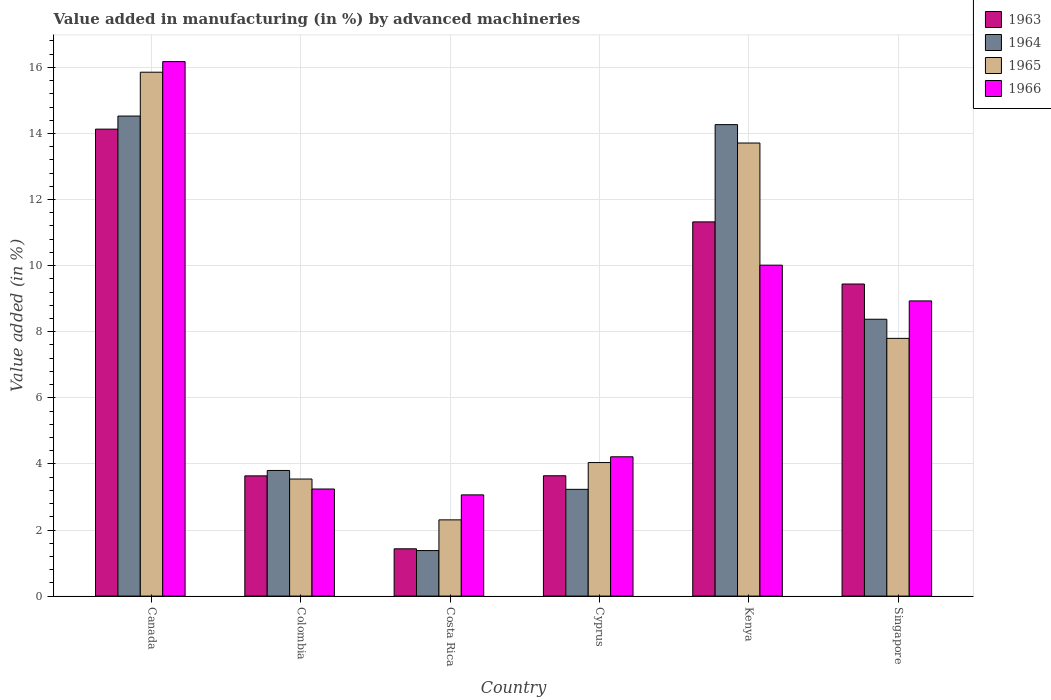How many groups of bars are there?
Your response must be concise. 6. Are the number of bars per tick equal to the number of legend labels?
Offer a very short reply. Yes. Are the number of bars on each tick of the X-axis equal?
Your answer should be compact. Yes. What is the label of the 4th group of bars from the left?
Provide a short and direct response. Cyprus. In how many cases, is the number of bars for a given country not equal to the number of legend labels?
Provide a short and direct response. 0. What is the percentage of value added in manufacturing by advanced machineries in 1965 in Cyprus?
Your response must be concise. 4.04. Across all countries, what is the maximum percentage of value added in manufacturing by advanced machineries in 1963?
Provide a short and direct response. 14.13. Across all countries, what is the minimum percentage of value added in manufacturing by advanced machineries in 1964?
Your response must be concise. 1.38. In which country was the percentage of value added in manufacturing by advanced machineries in 1966 maximum?
Offer a very short reply. Canada. What is the total percentage of value added in manufacturing by advanced machineries in 1963 in the graph?
Offer a terse response. 43.61. What is the difference between the percentage of value added in manufacturing by advanced machineries in 1963 in Colombia and that in Kenya?
Offer a terse response. -7.69. What is the difference between the percentage of value added in manufacturing by advanced machineries in 1965 in Canada and the percentage of value added in manufacturing by advanced machineries in 1964 in Colombia?
Ensure brevity in your answer.  12.05. What is the average percentage of value added in manufacturing by advanced machineries in 1966 per country?
Your answer should be very brief. 7.61. What is the difference between the percentage of value added in manufacturing by advanced machineries of/in 1966 and percentage of value added in manufacturing by advanced machineries of/in 1964 in Kenya?
Offer a terse response. -4.25. In how many countries, is the percentage of value added in manufacturing by advanced machineries in 1966 greater than 10 %?
Ensure brevity in your answer.  2. What is the ratio of the percentage of value added in manufacturing by advanced machineries in 1966 in Canada to that in Costa Rica?
Your response must be concise. 5.28. Is the percentage of value added in manufacturing by advanced machineries in 1966 in Colombia less than that in Kenya?
Make the answer very short. Yes. What is the difference between the highest and the second highest percentage of value added in manufacturing by advanced machineries in 1966?
Your response must be concise. 7.24. What is the difference between the highest and the lowest percentage of value added in manufacturing by advanced machineries in 1963?
Offer a terse response. 12.7. Is the sum of the percentage of value added in manufacturing by advanced machineries in 1965 in Colombia and Cyprus greater than the maximum percentage of value added in manufacturing by advanced machineries in 1964 across all countries?
Offer a very short reply. No. Is it the case that in every country, the sum of the percentage of value added in manufacturing by advanced machineries in 1966 and percentage of value added in manufacturing by advanced machineries in 1964 is greater than the sum of percentage of value added in manufacturing by advanced machineries in 1965 and percentage of value added in manufacturing by advanced machineries in 1963?
Make the answer very short. No. What does the 3rd bar from the left in Canada represents?
Make the answer very short. 1965. Are all the bars in the graph horizontal?
Offer a terse response. No. How many countries are there in the graph?
Give a very brief answer. 6. Are the values on the major ticks of Y-axis written in scientific E-notation?
Your response must be concise. No. Does the graph contain any zero values?
Keep it short and to the point. No. Where does the legend appear in the graph?
Your response must be concise. Top right. How many legend labels are there?
Offer a terse response. 4. What is the title of the graph?
Keep it short and to the point. Value added in manufacturing (in %) by advanced machineries. What is the label or title of the Y-axis?
Offer a very short reply. Value added (in %). What is the Value added (in %) of 1963 in Canada?
Give a very brief answer. 14.13. What is the Value added (in %) in 1964 in Canada?
Offer a very short reply. 14.53. What is the Value added (in %) of 1965 in Canada?
Your answer should be very brief. 15.85. What is the Value added (in %) in 1966 in Canada?
Provide a succinct answer. 16.17. What is the Value added (in %) of 1963 in Colombia?
Provide a short and direct response. 3.64. What is the Value added (in %) in 1964 in Colombia?
Ensure brevity in your answer.  3.8. What is the Value added (in %) in 1965 in Colombia?
Your answer should be very brief. 3.54. What is the Value added (in %) in 1966 in Colombia?
Keep it short and to the point. 3.24. What is the Value added (in %) of 1963 in Costa Rica?
Offer a very short reply. 1.43. What is the Value added (in %) in 1964 in Costa Rica?
Offer a very short reply. 1.38. What is the Value added (in %) of 1965 in Costa Rica?
Give a very brief answer. 2.31. What is the Value added (in %) of 1966 in Costa Rica?
Keep it short and to the point. 3.06. What is the Value added (in %) in 1963 in Cyprus?
Offer a very short reply. 3.64. What is the Value added (in %) of 1964 in Cyprus?
Provide a succinct answer. 3.23. What is the Value added (in %) of 1965 in Cyprus?
Give a very brief answer. 4.04. What is the Value added (in %) of 1966 in Cyprus?
Provide a succinct answer. 4.22. What is the Value added (in %) in 1963 in Kenya?
Provide a short and direct response. 11.32. What is the Value added (in %) of 1964 in Kenya?
Your answer should be compact. 14.27. What is the Value added (in %) of 1965 in Kenya?
Give a very brief answer. 13.71. What is the Value added (in %) of 1966 in Kenya?
Your answer should be compact. 10.01. What is the Value added (in %) of 1963 in Singapore?
Keep it short and to the point. 9.44. What is the Value added (in %) of 1964 in Singapore?
Keep it short and to the point. 8.38. What is the Value added (in %) of 1965 in Singapore?
Give a very brief answer. 7.8. What is the Value added (in %) in 1966 in Singapore?
Give a very brief answer. 8.93. Across all countries, what is the maximum Value added (in %) of 1963?
Provide a short and direct response. 14.13. Across all countries, what is the maximum Value added (in %) of 1964?
Ensure brevity in your answer.  14.53. Across all countries, what is the maximum Value added (in %) of 1965?
Keep it short and to the point. 15.85. Across all countries, what is the maximum Value added (in %) of 1966?
Offer a very short reply. 16.17. Across all countries, what is the minimum Value added (in %) of 1963?
Provide a short and direct response. 1.43. Across all countries, what is the minimum Value added (in %) of 1964?
Provide a succinct answer. 1.38. Across all countries, what is the minimum Value added (in %) in 1965?
Keep it short and to the point. 2.31. Across all countries, what is the minimum Value added (in %) in 1966?
Provide a short and direct response. 3.06. What is the total Value added (in %) of 1963 in the graph?
Keep it short and to the point. 43.61. What is the total Value added (in %) of 1964 in the graph?
Your answer should be very brief. 45.58. What is the total Value added (in %) in 1965 in the graph?
Provide a short and direct response. 47.25. What is the total Value added (in %) in 1966 in the graph?
Offer a very short reply. 45.64. What is the difference between the Value added (in %) of 1963 in Canada and that in Colombia?
Your answer should be compact. 10.49. What is the difference between the Value added (in %) of 1964 in Canada and that in Colombia?
Offer a terse response. 10.72. What is the difference between the Value added (in %) of 1965 in Canada and that in Colombia?
Keep it short and to the point. 12.31. What is the difference between the Value added (in %) in 1966 in Canada and that in Colombia?
Keep it short and to the point. 12.93. What is the difference between the Value added (in %) of 1963 in Canada and that in Costa Rica?
Make the answer very short. 12.7. What is the difference between the Value added (in %) of 1964 in Canada and that in Costa Rica?
Provide a succinct answer. 13.15. What is the difference between the Value added (in %) in 1965 in Canada and that in Costa Rica?
Make the answer very short. 13.55. What is the difference between the Value added (in %) of 1966 in Canada and that in Costa Rica?
Make the answer very short. 13.11. What is the difference between the Value added (in %) in 1963 in Canada and that in Cyprus?
Provide a short and direct response. 10.49. What is the difference between the Value added (in %) in 1964 in Canada and that in Cyprus?
Make the answer very short. 11.3. What is the difference between the Value added (in %) in 1965 in Canada and that in Cyprus?
Offer a terse response. 11.81. What is the difference between the Value added (in %) in 1966 in Canada and that in Cyprus?
Your answer should be very brief. 11.96. What is the difference between the Value added (in %) of 1963 in Canada and that in Kenya?
Offer a terse response. 2.81. What is the difference between the Value added (in %) in 1964 in Canada and that in Kenya?
Offer a very short reply. 0.26. What is the difference between the Value added (in %) of 1965 in Canada and that in Kenya?
Your response must be concise. 2.14. What is the difference between the Value added (in %) of 1966 in Canada and that in Kenya?
Your response must be concise. 6.16. What is the difference between the Value added (in %) in 1963 in Canada and that in Singapore?
Your answer should be very brief. 4.69. What is the difference between the Value added (in %) of 1964 in Canada and that in Singapore?
Provide a short and direct response. 6.15. What is the difference between the Value added (in %) of 1965 in Canada and that in Singapore?
Your answer should be very brief. 8.05. What is the difference between the Value added (in %) in 1966 in Canada and that in Singapore?
Provide a short and direct response. 7.24. What is the difference between the Value added (in %) of 1963 in Colombia and that in Costa Rica?
Your answer should be very brief. 2.21. What is the difference between the Value added (in %) in 1964 in Colombia and that in Costa Rica?
Your response must be concise. 2.42. What is the difference between the Value added (in %) in 1965 in Colombia and that in Costa Rica?
Your response must be concise. 1.24. What is the difference between the Value added (in %) of 1966 in Colombia and that in Costa Rica?
Give a very brief answer. 0.18. What is the difference between the Value added (in %) of 1963 in Colombia and that in Cyprus?
Provide a short and direct response. -0. What is the difference between the Value added (in %) in 1964 in Colombia and that in Cyprus?
Offer a terse response. 0.57. What is the difference between the Value added (in %) of 1965 in Colombia and that in Cyprus?
Offer a very short reply. -0.5. What is the difference between the Value added (in %) of 1966 in Colombia and that in Cyprus?
Your answer should be very brief. -0.97. What is the difference between the Value added (in %) of 1963 in Colombia and that in Kenya?
Make the answer very short. -7.69. What is the difference between the Value added (in %) of 1964 in Colombia and that in Kenya?
Ensure brevity in your answer.  -10.47. What is the difference between the Value added (in %) of 1965 in Colombia and that in Kenya?
Keep it short and to the point. -10.17. What is the difference between the Value added (in %) of 1966 in Colombia and that in Kenya?
Provide a short and direct response. -6.77. What is the difference between the Value added (in %) in 1963 in Colombia and that in Singapore?
Give a very brief answer. -5.81. What is the difference between the Value added (in %) of 1964 in Colombia and that in Singapore?
Provide a succinct answer. -4.58. What is the difference between the Value added (in %) in 1965 in Colombia and that in Singapore?
Provide a short and direct response. -4.26. What is the difference between the Value added (in %) in 1966 in Colombia and that in Singapore?
Offer a terse response. -5.69. What is the difference between the Value added (in %) of 1963 in Costa Rica and that in Cyprus?
Ensure brevity in your answer.  -2.21. What is the difference between the Value added (in %) of 1964 in Costa Rica and that in Cyprus?
Your response must be concise. -1.85. What is the difference between the Value added (in %) in 1965 in Costa Rica and that in Cyprus?
Keep it short and to the point. -1.73. What is the difference between the Value added (in %) in 1966 in Costa Rica and that in Cyprus?
Give a very brief answer. -1.15. What is the difference between the Value added (in %) of 1963 in Costa Rica and that in Kenya?
Your answer should be very brief. -9.89. What is the difference between the Value added (in %) of 1964 in Costa Rica and that in Kenya?
Ensure brevity in your answer.  -12.89. What is the difference between the Value added (in %) in 1965 in Costa Rica and that in Kenya?
Offer a very short reply. -11.4. What is the difference between the Value added (in %) of 1966 in Costa Rica and that in Kenya?
Provide a short and direct response. -6.95. What is the difference between the Value added (in %) of 1963 in Costa Rica and that in Singapore?
Give a very brief answer. -8.01. What is the difference between the Value added (in %) of 1964 in Costa Rica and that in Singapore?
Make the answer very short. -7. What is the difference between the Value added (in %) in 1965 in Costa Rica and that in Singapore?
Make the answer very short. -5.49. What is the difference between the Value added (in %) in 1966 in Costa Rica and that in Singapore?
Provide a succinct answer. -5.87. What is the difference between the Value added (in %) in 1963 in Cyprus and that in Kenya?
Make the answer very short. -7.68. What is the difference between the Value added (in %) in 1964 in Cyprus and that in Kenya?
Keep it short and to the point. -11.04. What is the difference between the Value added (in %) in 1965 in Cyprus and that in Kenya?
Your response must be concise. -9.67. What is the difference between the Value added (in %) of 1966 in Cyprus and that in Kenya?
Provide a succinct answer. -5.8. What is the difference between the Value added (in %) in 1963 in Cyprus and that in Singapore?
Make the answer very short. -5.8. What is the difference between the Value added (in %) in 1964 in Cyprus and that in Singapore?
Your answer should be very brief. -5.15. What is the difference between the Value added (in %) in 1965 in Cyprus and that in Singapore?
Provide a short and direct response. -3.76. What is the difference between the Value added (in %) in 1966 in Cyprus and that in Singapore?
Ensure brevity in your answer.  -4.72. What is the difference between the Value added (in %) of 1963 in Kenya and that in Singapore?
Give a very brief answer. 1.88. What is the difference between the Value added (in %) in 1964 in Kenya and that in Singapore?
Provide a short and direct response. 5.89. What is the difference between the Value added (in %) of 1965 in Kenya and that in Singapore?
Keep it short and to the point. 5.91. What is the difference between the Value added (in %) of 1966 in Kenya and that in Singapore?
Your answer should be very brief. 1.08. What is the difference between the Value added (in %) of 1963 in Canada and the Value added (in %) of 1964 in Colombia?
Your answer should be very brief. 10.33. What is the difference between the Value added (in %) of 1963 in Canada and the Value added (in %) of 1965 in Colombia?
Your answer should be compact. 10.59. What is the difference between the Value added (in %) of 1963 in Canada and the Value added (in %) of 1966 in Colombia?
Offer a very short reply. 10.89. What is the difference between the Value added (in %) in 1964 in Canada and the Value added (in %) in 1965 in Colombia?
Your response must be concise. 10.98. What is the difference between the Value added (in %) in 1964 in Canada and the Value added (in %) in 1966 in Colombia?
Give a very brief answer. 11.29. What is the difference between the Value added (in %) in 1965 in Canada and the Value added (in %) in 1966 in Colombia?
Offer a very short reply. 12.61. What is the difference between the Value added (in %) of 1963 in Canada and the Value added (in %) of 1964 in Costa Rica?
Your response must be concise. 12.75. What is the difference between the Value added (in %) of 1963 in Canada and the Value added (in %) of 1965 in Costa Rica?
Ensure brevity in your answer.  11.82. What is the difference between the Value added (in %) of 1963 in Canada and the Value added (in %) of 1966 in Costa Rica?
Your answer should be very brief. 11.07. What is the difference between the Value added (in %) of 1964 in Canada and the Value added (in %) of 1965 in Costa Rica?
Your response must be concise. 12.22. What is the difference between the Value added (in %) of 1964 in Canada and the Value added (in %) of 1966 in Costa Rica?
Offer a very short reply. 11.46. What is the difference between the Value added (in %) of 1965 in Canada and the Value added (in %) of 1966 in Costa Rica?
Your answer should be compact. 12.79. What is the difference between the Value added (in %) of 1963 in Canada and the Value added (in %) of 1964 in Cyprus?
Make the answer very short. 10.9. What is the difference between the Value added (in %) in 1963 in Canada and the Value added (in %) in 1965 in Cyprus?
Keep it short and to the point. 10.09. What is the difference between the Value added (in %) in 1963 in Canada and the Value added (in %) in 1966 in Cyprus?
Your answer should be very brief. 9.92. What is the difference between the Value added (in %) in 1964 in Canada and the Value added (in %) in 1965 in Cyprus?
Provide a succinct answer. 10.49. What is the difference between the Value added (in %) in 1964 in Canada and the Value added (in %) in 1966 in Cyprus?
Provide a short and direct response. 10.31. What is the difference between the Value added (in %) in 1965 in Canada and the Value added (in %) in 1966 in Cyprus?
Provide a short and direct response. 11.64. What is the difference between the Value added (in %) in 1963 in Canada and the Value added (in %) in 1964 in Kenya?
Offer a very short reply. -0.14. What is the difference between the Value added (in %) of 1963 in Canada and the Value added (in %) of 1965 in Kenya?
Your response must be concise. 0.42. What is the difference between the Value added (in %) in 1963 in Canada and the Value added (in %) in 1966 in Kenya?
Provide a short and direct response. 4.12. What is the difference between the Value added (in %) of 1964 in Canada and the Value added (in %) of 1965 in Kenya?
Your response must be concise. 0.82. What is the difference between the Value added (in %) of 1964 in Canada and the Value added (in %) of 1966 in Kenya?
Your response must be concise. 4.51. What is the difference between the Value added (in %) of 1965 in Canada and the Value added (in %) of 1966 in Kenya?
Ensure brevity in your answer.  5.84. What is the difference between the Value added (in %) in 1963 in Canada and the Value added (in %) in 1964 in Singapore?
Keep it short and to the point. 5.75. What is the difference between the Value added (in %) of 1963 in Canada and the Value added (in %) of 1965 in Singapore?
Your answer should be very brief. 6.33. What is the difference between the Value added (in %) of 1963 in Canada and the Value added (in %) of 1966 in Singapore?
Provide a short and direct response. 5.2. What is the difference between the Value added (in %) in 1964 in Canada and the Value added (in %) in 1965 in Singapore?
Offer a very short reply. 6.73. What is the difference between the Value added (in %) of 1964 in Canada and the Value added (in %) of 1966 in Singapore?
Your answer should be very brief. 5.59. What is the difference between the Value added (in %) in 1965 in Canada and the Value added (in %) in 1966 in Singapore?
Provide a short and direct response. 6.92. What is the difference between the Value added (in %) in 1963 in Colombia and the Value added (in %) in 1964 in Costa Rica?
Make the answer very short. 2.26. What is the difference between the Value added (in %) in 1963 in Colombia and the Value added (in %) in 1965 in Costa Rica?
Your answer should be very brief. 1.33. What is the difference between the Value added (in %) of 1963 in Colombia and the Value added (in %) of 1966 in Costa Rica?
Your answer should be very brief. 0.57. What is the difference between the Value added (in %) in 1964 in Colombia and the Value added (in %) in 1965 in Costa Rica?
Provide a short and direct response. 1.49. What is the difference between the Value added (in %) of 1964 in Colombia and the Value added (in %) of 1966 in Costa Rica?
Your response must be concise. 0.74. What is the difference between the Value added (in %) of 1965 in Colombia and the Value added (in %) of 1966 in Costa Rica?
Provide a succinct answer. 0.48. What is the difference between the Value added (in %) of 1963 in Colombia and the Value added (in %) of 1964 in Cyprus?
Provide a succinct answer. 0.41. What is the difference between the Value added (in %) of 1963 in Colombia and the Value added (in %) of 1965 in Cyprus?
Make the answer very short. -0.4. What is the difference between the Value added (in %) of 1963 in Colombia and the Value added (in %) of 1966 in Cyprus?
Your response must be concise. -0.58. What is the difference between the Value added (in %) of 1964 in Colombia and the Value added (in %) of 1965 in Cyprus?
Keep it short and to the point. -0.24. What is the difference between the Value added (in %) in 1964 in Colombia and the Value added (in %) in 1966 in Cyprus?
Your response must be concise. -0.41. What is the difference between the Value added (in %) of 1965 in Colombia and the Value added (in %) of 1966 in Cyprus?
Your response must be concise. -0.67. What is the difference between the Value added (in %) in 1963 in Colombia and the Value added (in %) in 1964 in Kenya?
Provide a short and direct response. -10.63. What is the difference between the Value added (in %) of 1963 in Colombia and the Value added (in %) of 1965 in Kenya?
Offer a very short reply. -10.07. What is the difference between the Value added (in %) of 1963 in Colombia and the Value added (in %) of 1966 in Kenya?
Your response must be concise. -6.38. What is the difference between the Value added (in %) of 1964 in Colombia and the Value added (in %) of 1965 in Kenya?
Make the answer very short. -9.91. What is the difference between the Value added (in %) in 1964 in Colombia and the Value added (in %) in 1966 in Kenya?
Provide a succinct answer. -6.21. What is the difference between the Value added (in %) of 1965 in Colombia and the Value added (in %) of 1966 in Kenya?
Give a very brief answer. -6.47. What is the difference between the Value added (in %) in 1963 in Colombia and the Value added (in %) in 1964 in Singapore?
Make the answer very short. -4.74. What is the difference between the Value added (in %) of 1963 in Colombia and the Value added (in %) of 1965 in Singapore?
Provide a short and direct response. -4.16. What is the difference between the Value added (in %) in 1963 in Colombia and the Value added (in %) in 1966 in Singapore?
Offer a terse response. -5.29. What is the difference between the Value added (in %) in 1964 in Colombia and the Value added (in %) in 1965 in Singapore?
Make the answer very short. -4. What is the difference between the Value added (in %) in 1964 in Colombia and the Value added (in %) in 1966 in Singapore?
Make the answer very short. -5.13. What is the difference between the Value added (in %) in 1965 in Colombia and the Value added (in %) in 1966 in Singapore?
Provide a succinct answer. -5.39. What is the difference between the Value added (in %) in 1963 in Costa Rica and the Value added (in %) in 1964 in Cyprus?
Your answer should be compact. -1.8. What is the difference between the Value added (in %) of 1963 in Costa Rica and the Value added (in %) of 1965 in Cyprus?
Offer a very short reply. -2.61. What is the difference between the Value added (in %) of 1963 in Costa Rica and the Value added (in %) of 1966 in Cyprus?
Offer a terse response. -2.78. What is the difference between the Value added (in %) of 1964 in Costa Rica and the Value added (in %) of 1965 in Cyprus?
Keep it short and to the point. -2.66. What is the difference between the Value added (in %) of 1964 in Costa Rica and the Value added (in %) of 1966 in Cyprus?
Offer a terse response. -2.84. What is the difference between the Value added (in %) of 1965 in Costa Rica and the Value added (in %) of 1966 in Cyprus?
Provide a short and direct response. -1.91. What is the difference between the Value added (in %) of 1963 in Costa Rica and the Value added (in %) of 1964 in Kenya?
Offer a very short reply. -12.84. What is the difference between the Value added (in %) of 1963 in Costa Rica and the Value added (in %) of 1965 in Kenya?
Offer a terse response. -12.28. What is the difference between the Value added (in %) in 1963 in Costa Rica and the Value added (in %) in 1966 in Kenya?
Give a very brief answer. -8.58. What is the difference between the Value added (in %) in 1964 in Costa Rica and the Value added (in %) in 1965 in Kenya?
Offer a terse response. -12.33. What is the difference between the Value added (in %) in 1964 in Costa Rica and the Value added (in %) in 1966 in Kenya?
Give a very brief answer. -8.64. What is the difference between the Value added (in %) of 1965 in Costa Rica and the Value added (in %) of 1966 in Kenya?
Make the answer very short. -7.71. What is the difference between the Value added (in %) in 1963 in Costa Rica and the Value added (in %) in 1964 in Singapore?
Keep it short and to the point. -6.95. What is the difference between the Value added (in %) in 1963 in Costa Rica and the Value added (in %) in 1965 in Singapore?
Ensure brevity in your answer.  -6.37. What is the difference between the Value added (in %) in 1963 in Costa Rica and the Value added (in %) in 1966 in Singapore?
Offer a terse response. -7.5. What is the difference between the Value added (in %) in 1964 in Costa Rica and the Value added (in %) in 1965 in Singapore?
Your answer should be compact. -6.42. What is the difference between the Value added (in %) in 1964 in Costa Rica and the Value added (in %) in 1966 in Singapore?
Your response must be concise. -7.55. What is the difference between the Value added (in %) in 1965 in Costa Rica and the Value added (in %) in 1966 in Singapore?
Offer a very short reply. -6.63. What is the difference between the Value added (in %) of 1963 in Cyprus and the Value added (in %) of 1964 in Kenya?
Your response must be concise. -10.63. What is the difference between the Value added (in %) in 1963 in Cyprus and the Value added (in %) in 1965 in Kenya?
Offer a very short reply. -10.07. What is the difference between the Value added (in %) in 1963 in Cyprus and the Value added (in %) in 1966 in Kenya?
Your answer should be compact. -6.37. What is the difference between the Value added (in %) in 1964 in Cyprus and the Value added (in %) in 1965 in Kenya?
Offer a very short reply. -10.48. What is the difference between the Value added (in %) of 1964 in Cyprus and the Value added (in %) of 1966 in Kenya?
Your answer should be compact. -6.78. What is the difference between the Value added (in %) in 1965 in Cyprus and the Value added (in %) in 1966 in Kenya?
Offer a terse response. -5.97. What is the difference between the Value added (in %) in 1963 in Cyprus and the Value added (in %) in 1964 in Singapore?
Give a very brief answer. -4.74. What is the difference between the Value added (in %) of 1963 in Cyprus and the Value added (in %) of 1965 in Singapore?
Provide a succinct answer. -4.16. What is the difference between the Value added (in %) in 1963 in Cyprus and the Value added (in %) in 1966 in Singapore?
Make the answer very short. -5.29. What is the difference between the Value added (in %) of 1964 in Cyprus and the Value added (in %) of 1965 in Singapore?
Ensure brevity in your answer.  -4.57. What is the difference between the Value added (in %) of 1964 in Cyprus and the Value added (in %) of 1966 in Singapore?
Keep it short and to the point. -5.7. What is the difference between the Value added (in %) of 1965 in Cyprus and the Value added (in %) of 1966 in Singapore?
Provide a succinct answer. -4.89. What is the difference between the Value added (in %) of 1963 in Kenya and the Value added (in %) of 1964 in Singapore?
Keep it short and to the point. 2.95. What is the difference between the Value added (in %) of 1963 in Kenya and the Value added (in %) of 1965 in Singapore?
Provide a succinct answer. 3.52. What is the difference between the Value added (in %) of 1963 in Kenya and the Value added (in %) of 1966 in Singapore?
Offer a terse response. 2.39. What is the difference between the Value added (in %) of 1964 in Kenya and the Value added (in %) of 1965 in Singapore?
Your answer should be compact. 6.47. What is the difference between the Value added (in %) in 1964 in Kenya and the Value added (in %) in 1966 in Singapore?
Offer a terse response. 5.33. What is the difference between the Value added (in %) of 1965 in Kenya and the Value added (in %) of 1966 in Singapore?
Provide a short and direct response. 4.78. What is the average Value added (in %) of 1963 per country?
Offer a terse response. 7.27. What is the average Value added (in %) of 1964 per country?
Make the answer very short. 7.6. What is the average Value added (in %) in 1965 per country?
Your response must be concise. 7.88. What is the average Value added (in %) in 1966 per country?
Keep it short and to the point. 7.61. What is the difference between the Value added (in %) of 1963 and Value added (in %) of 1964 in Canada?
Keep it short and to the point. -0.4. What is the difference between the Value added (in %) in 1963 and Value added (in %) in 1965 in Canada?
Your answer should be compact. -1.72. What is the difference between the Value added (in %) of 1963 and Value added (in %) of 1966 in Canada?
Give a very brief answer. -2.04. What is the difference between the Value added (in %) of 1964 and Value added (in %) of 1965 in Canada?
Provide a succinct answer. -1.33. What is the difference between the Value added (in %) of 1964 and Value added (in %) of 1966 in Canada?
Your answer should be very brief. -1.65. What is the difference between the Value added (in %) of 1965 and Value added (in %) of 1966 in Canada?
Your response must be concise. -0.32. What is the difference between the Value added (in %) of 1963 and Value added (in %) of 1964 in Colombia?
Your answer should be compact. -0.16. What is the difference between the Value added (in %) of 1963 and Value added (in %) of 1965 in Colombia?
Make the answer very short. 0.1. What is the difference between the Value added (in %) of 1963 and Value added (in %) of 1966 in Colombia?
Give a very brief answer. 0.4. What is the difference between the Value added (in %) of 1964 and Value added (in %) of 1965 in Colombia?
Offer a terse response. 0.26. What is the difference between the Value added (in %) of 1964 and Value added (in %) of 1966 in Colombia?
Offer a terse response. 0.56. What is the difference between the Value added (in %) of 1965 and Value added (in %) of 1966 in Colombia?
Your response must be concise. 0.3. What is the difference between the Value added (in %) in 1963 and Value added (in %) in 1964 in Costa Rica?
Your response must be concise. 0.05. What is the difference between the Value added (in %) of 1963 and Value added (in %) of 1965 in Costa Rica?
Your response must be concise. -0.88. What is the difference between the Value added (in %) in 1963 and Value added (in %) in 1966 in Costa Rica?
Offer a very short reply. -1.63. What is the difference between the Value added (in %) of 1964 and Value added (in %) of 1965 in Costa Rica?
Give a very brief answer. -0.93. What is the difference between the Value added (in %) of 1964 and Value added (in %) of 1966 in Costa Rica?
Offer a very short reply. -1.69. What is the difference between the Value added (in %) in 1965 and Value added (in %) in 1966 in Costa Rica?
Ensure brevity in your answer.  -0.76. What is the difference between the Value added (in %) of 1963 and Value added (in %) of 1964 in Cyprus?
Offer a terse response. 0.41. What is the difference between the Value added (in %) of 1963 and Value added (in %) of 1965 in Cyprus?
Your answer should be very brief. -0.4. What is the difference between the Value added (in %) in 1963 and Value added (in %) in 1966 in Cyprus?
Keep it short and to the point. -0.57. What is the difference between the Value added (in %) of 1964 and Value added (in %) of 1965 in Cyprus?
Offer a very short reply. -0.81. What is the difference between the Value added (in %) in 1964 and Value added (in %) in 1966 in Cyprus?
Keep it short and to the point. -0.98. What is the difference between the Value added (in %) of 1965 and Value added (in %) of 1966 in Cyprus?
Offer a terse response. -0.17. What is the difference between the Value added (in %) of 1963 and Value added (in %) of 1964 in Kenya?
Make the answer very short. -2.94. What is the difference between the Value added (in %) of 1963 and Value added (in %) of 1965 in Kenya?
Your answer should be compact. -2.39. What is the difference between the Value added (in %) of 1963 and Value added (in %) of 1966 in Kenya?
Your answer should be compact. 1.31. What is the difference between the Value added (in %) in 1964 and Value added (in %) in 1965 in Kenya?
Offer a very short reply. 0.56. What is the difference between the Value added (in %) in 1964 and Value added (in %) in 1966 in Kenya?
Your response must be concise. 4.25. What is the difference between the Value added (in %) in 1965 and Value added (in %) in 1966 in Kenya?
Keep it short and to the point. 3.7. What is the difference between the Value added (in %) of 1963 and Value added (in %) of 1964 in Singapore?
Offer a terse response. 1.07. What is the difference between the Value added (in %) of 1963 and Value added (in %) of 1965 in Singapore?
Provide a short and direct response. 1.64. What is the difference between the Value added (in %) in 1963 and Value added (in %) in 1966 in Singapore?
Your answer should be very brief. 0.51. What is the difference between the Value added (in %) of 1964 and Value added (in %) of 1965 in Singapore?
Offer a terse response. 0.58. What is the difference between the Value added (in %) of 1964 and Value added (in %) of 1966 in Singapore?
Provide a short and direct response. -0.55. What is the difference between the Value added (in %) in 1965 and Value added (in %) in 1966 in Singapore?
Give a very brief answer. -1.13. What is the ratio of the Value added (in %) in 1963 in Canada to that in Colombia?
Your response must be concise. 3.88. What is the ratio of the Value added (in %) of 1964 in Canada to that in Colombia?
Make the answer very short. 3.82. What is the ratio of the Value added (in %) of 1965 in Canada to that in Colombia?
Your answer should be very brief. 4.48. What is the ratio of the Value added (in %) in 1966 in Canada to that in Colombia?
Your answer should be compact. 4.99. What is the ratio of the Value added (in %) in 1963 in Canada to that in Costa Rica?
Keep it short and to the point. 9.87. What is the ratio of the Value added (in %) in 1964 in Canada to that in Costa Rica?
Offer a terse response. 10.54. What is the ratio of the Value added (in %) in 1965 in Canada to that in Costa Rica?
Your answer should be compact. 6.87. What is the ratio of the Value added (in %) in 1966 in Canada to that in Costa Rica?
Offer a terse response. 5.28. What is the ratio of the Value added (in %) of 1963 in Canada to that in Cyprus?
Make the answer very short. 3.88. What is the ratio of the Value added (in %) of 1964 in Canada to that in Cyprus?
Your response must be concise. 4.5. What is the ratio of the Value added (in %) of 1965 in Canada to that in Cyprus?
Offer a terse response. 3.92. What is the ratio of the Value added (in %) in 1966 in Canada to that in Cyprus?
Make the answer very short. 3.84. What is the ratio of the Value added (in %) of 1963 in Canada to that in Kenya?
Give a very brief answer. 1.25. What is the ratio of the Value added (in %) of 1964 in Canada to that in Kenya?
Keep it short and to the point. 1.02. What is the ratio of the Value added (in %) of 1965 in Canada to that in Kenya?
Make the answer very short. 1.16. What is the ratio of the Value added (in %) of 1966 in Canada to that in Kenya?
Provide a short and direct response. 1.62. What is the ratio of the Value added (in %) of 1963 in Canada to that in Singapore?
Provide a succinct answer. 1.5. What is the ratio of the Value added (in %) of 1964 in Canada to that in Singapore?
Keep it short and to the point. 1.73. What is the ratio of the Value added (in %) of 1965 in Canada to that in Singapore?
Ensure brevity in your answer.  2.03. What is the ratio of the Value added (in %) of 1966 in Canada to that in Singapore?
Keep it short and to the point. 1.81. What is the ratio of the Value added (in %) of 1963 in Colombia to that in Costa Rica?
Provide a succinct answer. 2.54. What is the ratio of the Value added (in %) of 1964 in Colombia to that in Costa Rica?
Your answer should be compact. 2.76. What is the ratio of the Value added (in %) of 1965 in Colombia to that in Costa Rica?
Offer a terse response. 1.54. What is the ratio of the Value added (in %) in 1966 in Colombia to that in Costa Rica?
Provide a succinct answer. 1.06. What is the ratio of the Value added (in %) in 1963 in Colombia to that in Cyprus?
Your answer should be compact. 1. What is the ratio of the Value added (in %) in 1964 in Colombia to that in Cyprus?
Your response must be concise. 1.18. What is the ratio of the Value added (in %) in 1965 in Colombia to that in Cyprus?
Ensure brevity in your answer.  0.88. What is the ratio of the Value added (in %) in 1966 in Colombia to that in Cyprus?
Offer a terse response. 0.77. What is the ratio of the Value added (in %) of 1963 in Colombia to that in Kenya?
Give a very brief answer. 0.32. What is the ratio of the Value added (in %) in 1964 in Colombia to that in Kenya?
Ensure brevity in your answer.  0.27. What is the ratio of the Value added (in %) in 1965 in Colombia to that in Kenya?
Give a very brief answer. 0.26. What is the ratio of the Value added (in %) of 1966 in Colombia to that in Kenya?
Offer a terse response. 0.32. What is the ratio of the Value added (in %) in 1963 in Colombia to that in Singapore?
Your answer should be very brief. 0.39. What is the ratio of the Value added (in %) in 1964 in Colombia to that in Singapore?
Keep it short and to the point. 0.45. What is the ratio of the Value added (in %) of 1965 in Colombia to that in Singapore?
Your answer should be compact. 0.45. What is the ratio of the Value added (in %) in 1966 in Colombia to that in Singapore?
Provide a short and direct response. 0.36. What is the ratio of the Value added (in %) of 1963 in Costa Rica to that in Cyprus?
Offer a terse response. 0.39. What is the ratio of the Value added (in %) in 1964 in Costa Rica to that in Cyprus?
Keep it short and to the point. 0.43. What is the ratio of the Value added (in %) of 1965 in Costa Rica to that in Cyprus?
Offer a very short reply. 0.57. What is the ratio of the Value added (in %) of 1966 in Costa Rica to that in Cyprus?
Offer a terse response. 0.73. What is the ratio of the Value added (in %) of 1963 in Costa Rica to that in Kenya?
Your answer should be compact. 0.13. What is the ratio of the Value added (in %) of 1964 in Costa Rica to that in Kenya?
Offer a very short reply. 0.1. What is the ratio of the Value added (in %) of 1965 in Costa Rica to that in Kenya?
Offer a terse response. 0.17. What is the ratio of the Value added (in %) in 1966 in Costa Rica to that in Kenya?
Keep it short and to the point. 0.31. What is the ratio of the Value added (in %) of 1963 in Costa Rica to that in Singapore?
Keep it short and to the point. 0.15. What is the ratio of the Value added (in %) of 1964 in Costa Rica to that in Singapore?
Your answer should be compact. 0.16. What is the ratio of the Value added (in %) in 1965 in Costa Rica to that in Singapore?
Offer a very short reply. 0.3. What is the ratio of the Value added (in %) in 1966 in Costa Rica to that in Singapore?
Your answer should be compact. 0.34. What is the ratio of the Value added (in %) of 1963 in Cyprus to that in Kenya?
Offer a terse response. 0.32. What is the ratio of the Value added (in %) of 1964 in Cyprus to that in Kenya?
Your answer should be compact. 0.23. What is the ratio of the Value added (in %) in 1965 in Cyprus to that in Kenya?
Your answer should be compact. 0.29. What is the ratio of the Value added (in %) in 1966 in Cyprus to that in Kenya?
Your answer should be very brief. 0.42. What is the ratio of the Value added (in %) of 1963 in Cyprus to that in Singapore?
Your response must be concise. 0.39. What is the ratio of the Value added (in %) of 1964 in Cyprus to that in Singapore?
Your response must be concise. 0.39. What is the ratio of the Value added (in %) of 1965 in Cyprus to that in Singapore?
Provide a succinct answer. 0.52. What is the ratio of the Value added (in %) of 1966 in Cyprus to that in Singapore?
Your response must be concise. 0.47. What is the ratio of the Value added (in %) of 1963 in Kenya to that in Singapore?
Give a very brief answer. 1.2. What is the ratio of the Value added (in %) of 1964 in Kenya to that in Singapore?
Offer a terse response. 1.7. What is the ratio of the Value added (in %) in 1965 in Kenya to that in Singapore?
Make the answer very short. 1.76. What is the ratio of the Value added (in %) in 1966 in Kenya to that in Singapore?
Your response must be concise. 1.12. What is the difference between the highest and the second highest Value added (in %) in 1963?
Keep it short and to the point. 2.81. What is the difference between the highest and the second highest Value added (in %) in 1964?
Make the answer very short. 0.26. What is the difference between the highest and the second highest Value added (in %) in 1965?
Offer a very short reply. 2.14. What is the difference between the highest and the second highest Value added (in %) in 1966?
Your response must be concise. 6.16. What is the difference between the highest and the lowest Value added (in %) of 1963?
Offer a very short reply. 12.7. What is the difference between the highest and the lowest Value added (in %) of 1964?
Your answer should be compact. 13.15. What is the difference between the highest and the lowest Value added (in %) in 1965?
Offer a terse response. 13.55. What is the difference between the highest and the lowest Value added (in %) in 1966?
Your answer should be very brief. 13.11. 